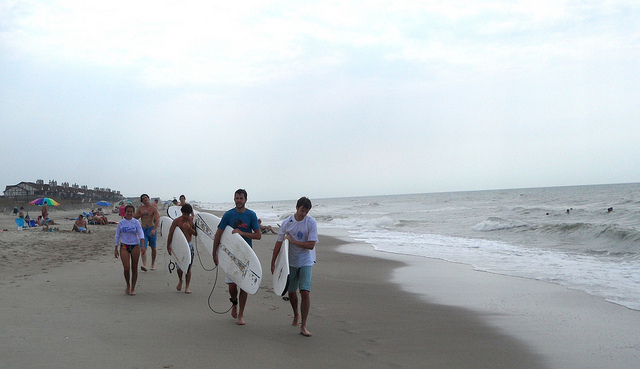How many cars are shown? 0 